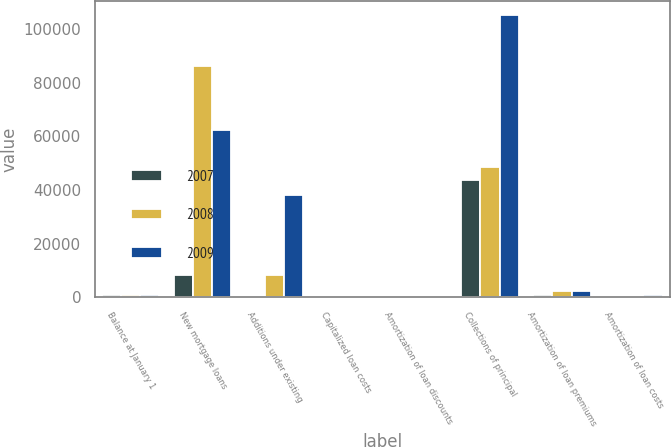<chart> <loc_0><loc_0><loc_500><loc_500><stacked_bar_chart><ecel><fcel>Balance at January 1<fcel>New mortgage loans<fcel>Additions under existing<fcel>Capitalized loan costs<fcel>Amortization of loan discounts<fcel>Collections of principal<fcel>Amortization of loan premiums<fcel>Amortization of loan costs<nl><fcel>2007<fcel>1024<fcel>8316<fcel>707<fcel>60<fcel>247<fcel>43578<fcel>1024<fcel>600<nl><fcel>2008<fcel>1024<fcel>86247<fcel>8268<fcel>605<fcel>247<fcel>48633<fcel>2279<fcel>680<nl><fcel>2009<fcel>1024<fcel>62362<fcel>38122<fcel>675<fcel>271<fcel>105277<fcel>2298<fcel>840<nl></chart> 